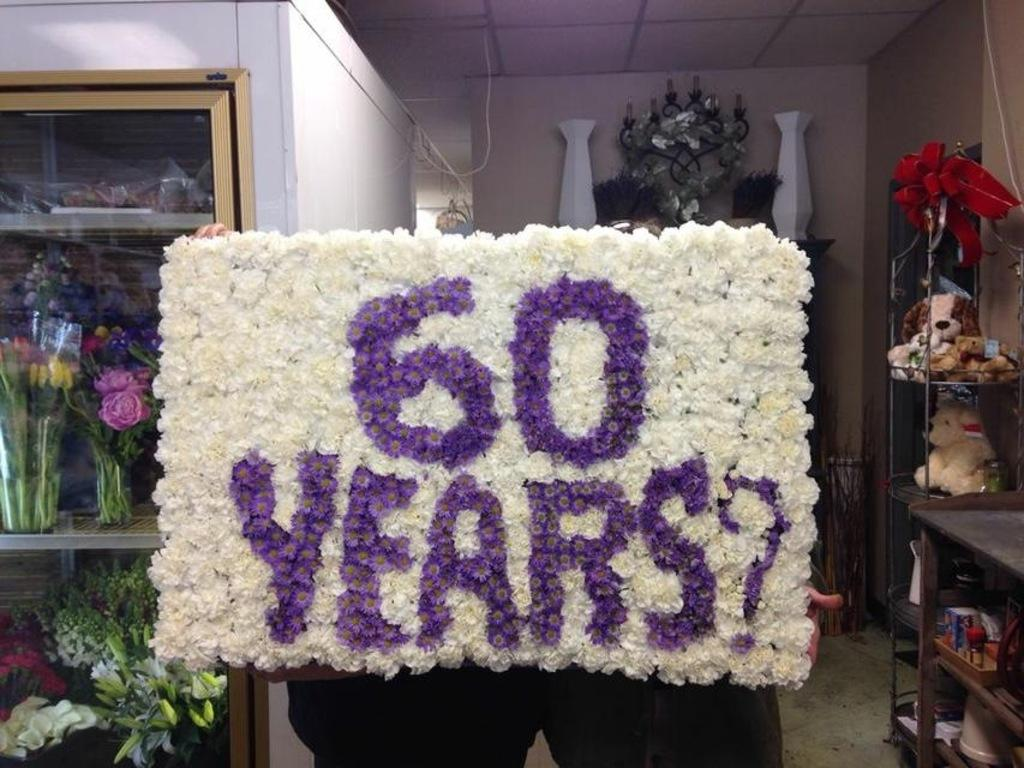Provide a one-sentence caption for the provided image. Sixtry years banner with flowers and vases near. 